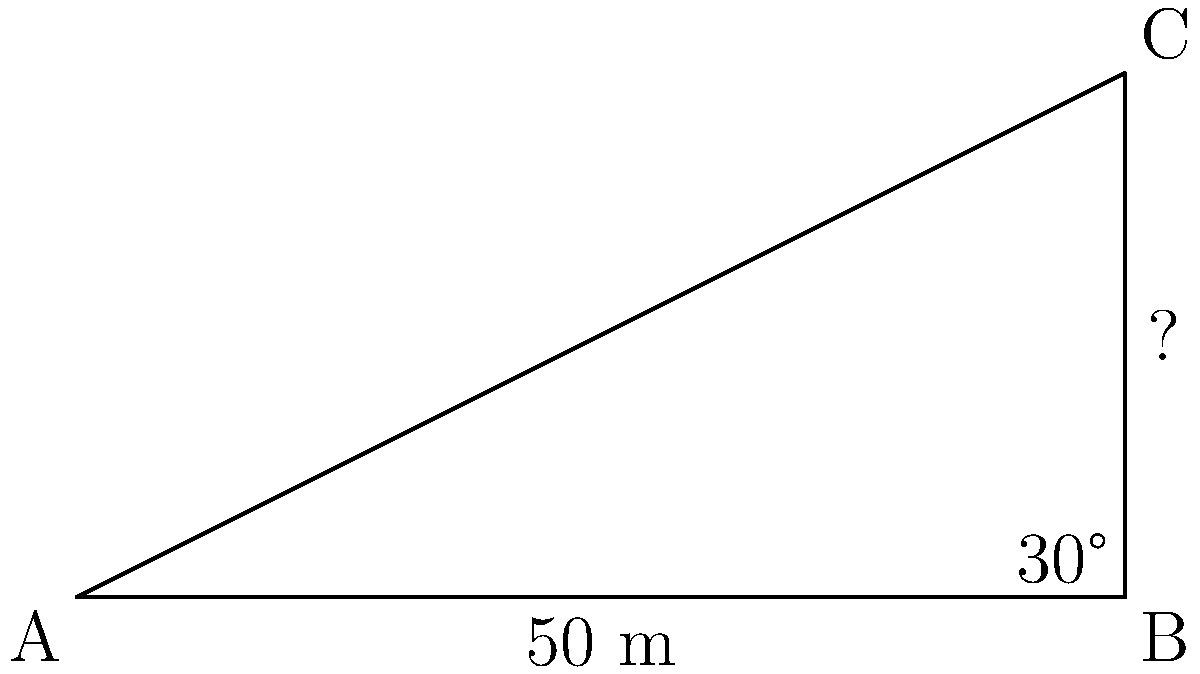During a literature-inspired field trip, you want to estimate the height of a Victorian-era building mentioned in a classic novel. Standing 50 meters away from the base of the building, you use a clinometer to measure the angle of elevation to the top of the building as 30°. What is the height of the building to the nearest meter? Let's approach this step-by-step:

1) We can model this situation as a right triangle, where:
   - The base of the triangle is the distance from you to the building (50 m)
   - The height of the triangle is the height of the building (what we're solving for)
   - The angle at the base is the angle of elevation (30°)

2) In this right triangle, we know:
   - The adjacent side (base) = 50 m
   - The angle = 30°
   - We need to find the opposite side (height)

3) This is a perfect scenario to use the tangent function:

   $\tan(\theta) = \frac{\text{opposite}}{\text{adjacent}}$

4) Plugging in our known values:

   $\tan(30°) = \frac{\text{height}}{50}$

5) To solve for the height, we multiply both sides by 50:

   $50 \cdot \tan(30°) = \text{height}$

6) Now, let's calculate:
   $\text{height} = 50 \cdot \tan(30°)$
   $= 50 \cdot 0.5773... $
   $= 28.8675...$

7) Rounding to the nearest meter:
   $\text{height} \approx 29 \text{ meters}$
Answer: 29 meters 